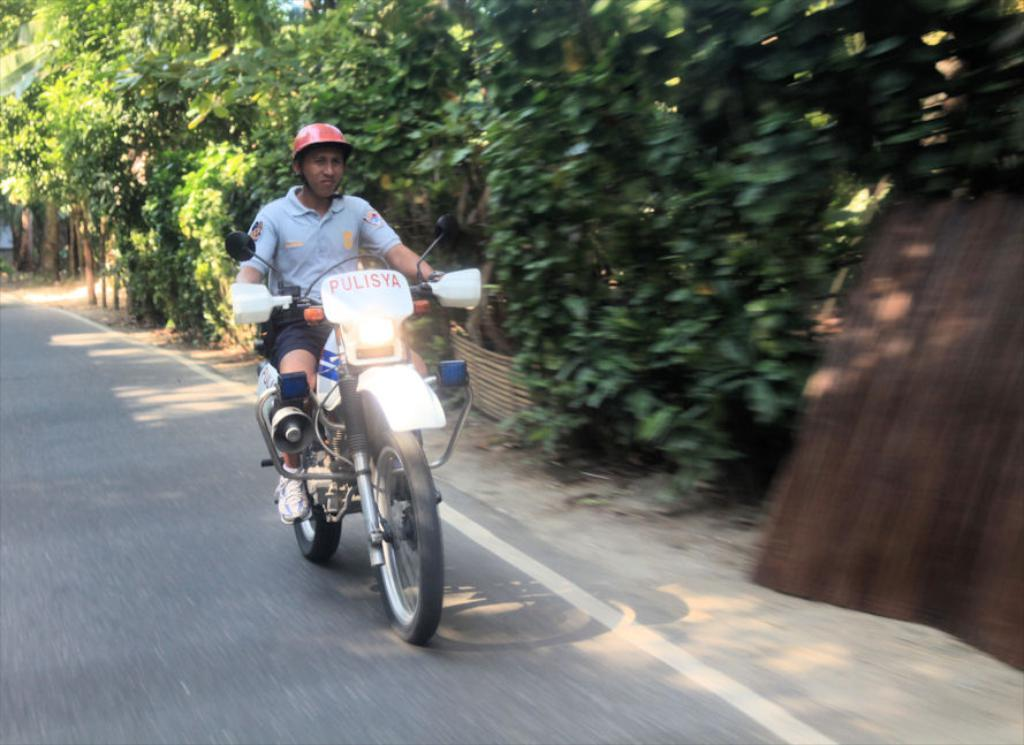What is the main subject of the image? There is a man in the image. What is the man doing in the image? The man is riding a motorcycle. What is the man wearing on his head? The man is wearing a red helmet. What can be seen in the background of the image? There are trees in the background of the image. What is the man's level of fear while riding the motorcycle in the image? The image does not provide any information about the man's emotions or feelings, so we cannot determine his level of fear. 